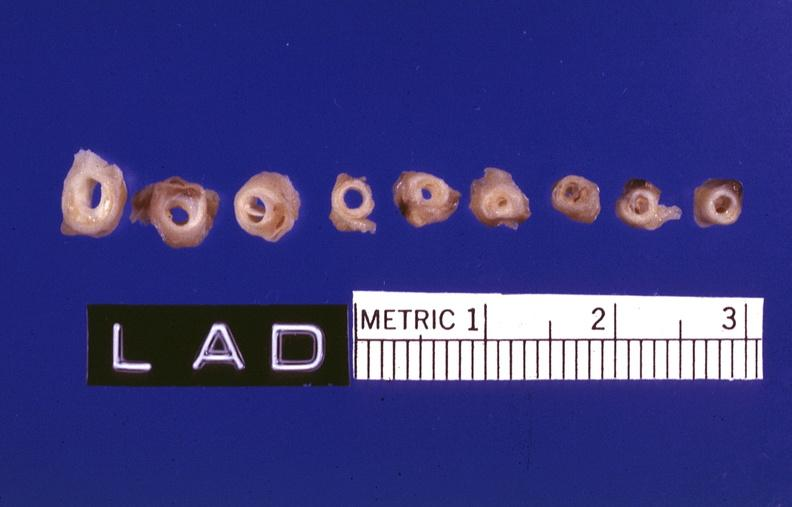s beckwith-wiedemann syndrome present?
Answer the question using a single word or phrase. No 